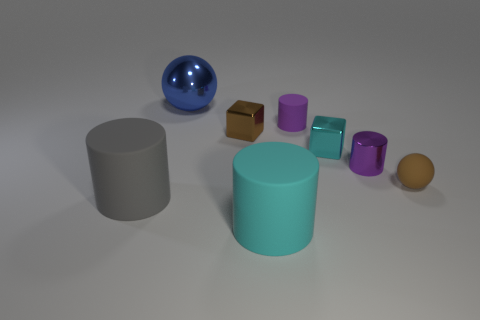What is the color of the large ball?
Offer a very short reply. Blue. There is a matte cylinder to the left of the cyan cylinder that is in front of the purple thing on the right side of the small cyan cube; what is its size?
Give a very brief answer. Large. How many other things are the same shape as the tiny purple matte object?
Make the answer very short. 3. What color is the rubber object that is behind the gray matte cylinder and on the left side of the small brown matte thing?
Offer a terse response. Purple. Is the color of the rubber cylinder behind the big gray thing the same as the metallic cylinder?
Keep it short and to the point. Yes. How many balls are either large gray rubber objects or brown shiny things?
Offer a very short reply. 0. There is a tiny purple thing in front of the purple rubber object; what is its shape?
Offer a terse response. Cylinder. There is a large object that is in front of the big matte thing left of the big object that is behind the tiny brown ball; what color is it?
Make the answer very short. Cyan. Do the brown cube and the gray cylinder have the same material?
Your response must be concise. No. How many gray things are tiny matte objects or matte cylinders?
Give a very brief answer. 1. 